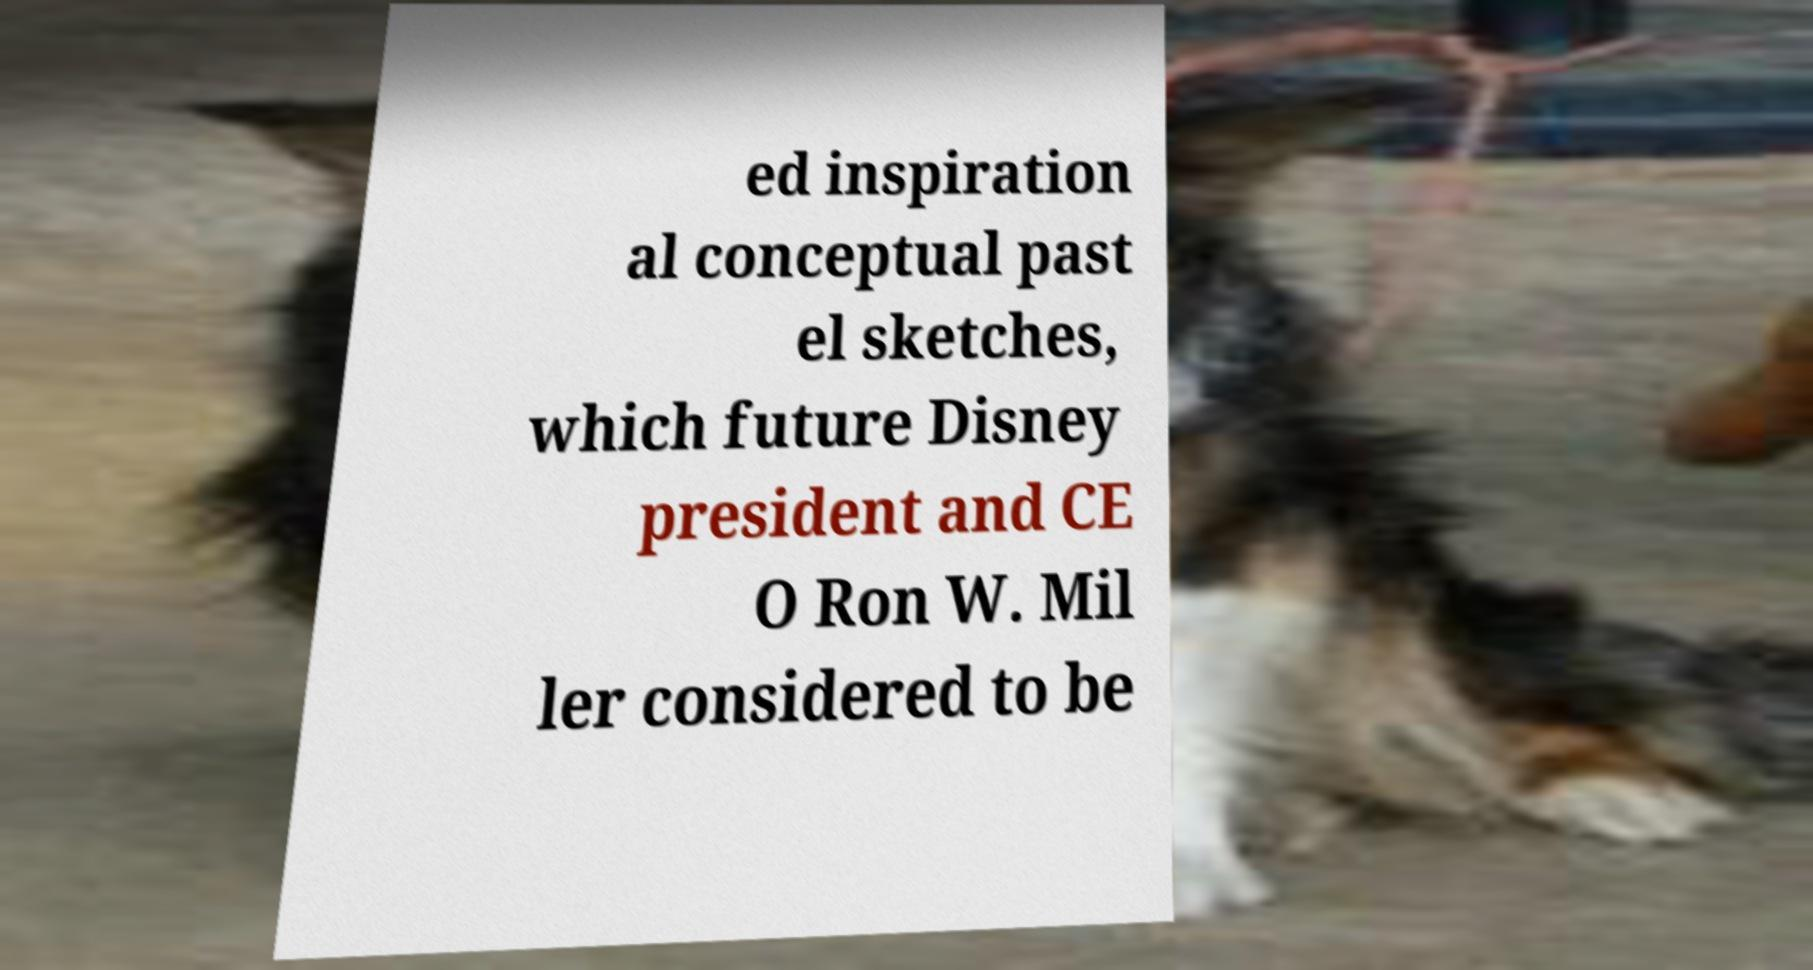There's text embedded in this image that I need extracted. Can you transcribe it verbatim? ed inspiration al conceptual past el sketches, which future Disney president and CE O Ron W. Mil ler considered to be 